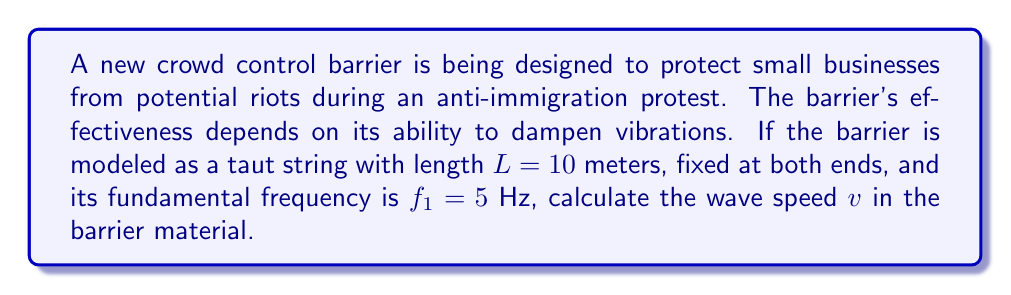Show me your answer to this math problem. To solve this problem, we'll use the wave equation for a vibrating string:

1) The fundamental frequency $f_1$ of a vibrating string is related to its length $L$ and wave speed $v$ by the equation:

   $$f_1 = \frac{v}{2L}$$

2) We are given:
   $f_1 = 5$ Hz
   $L = 10$ meters

3) Rearranging the equation to solve for $v$:

   $$v = 2Lf_1$$

4) Substituting the known values:

   $$v = 2 \cdot 10 \text{ m} \cdot 5 \text{ Hz}$$

5) Calculating:

   $$v = 100 \text{ m/s}$$

Thus, the wave speed in the barrier material is 100 meters per second.
Answer: $v = 100 \text{ m/s}$ 